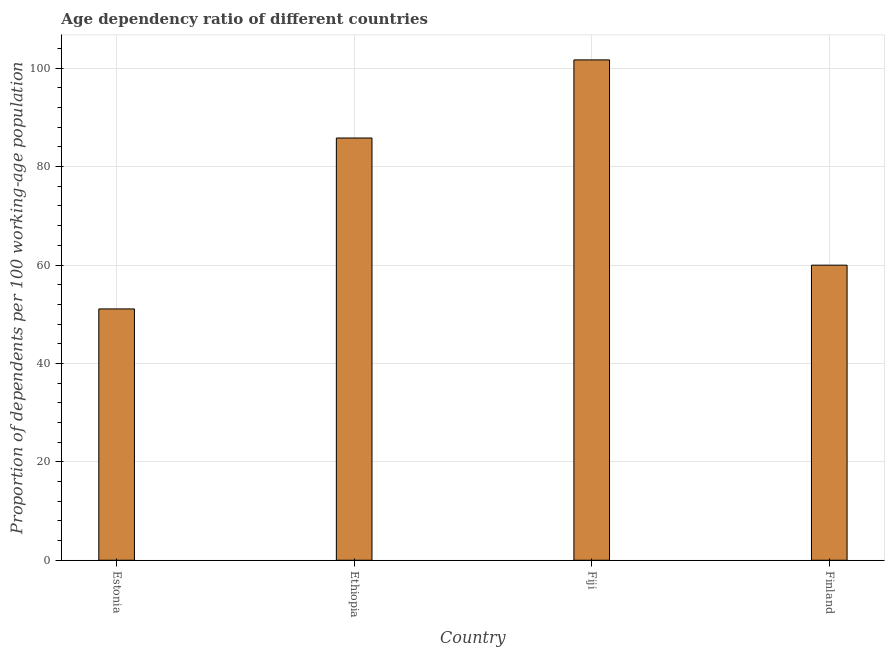Does the graph contain any zero values?
Provide a short and direct response. No. What is the title of the graph?
Your answer should be compact. Age dependency ratio of different countries. What is the label or title of the X-axis?
Your response must be concise. Country. What is the label or title of the Y-axis?
Make the answer very short. Proportion of dependents per 100 working-age population. What is the age dependency ratio in Fiji?
Offer a terse response. 101.69. Across all countries, what is the maximum age dependency ratio?
Your answer should be compact. 101.69. Across all countries, what is the minimum age dependency ratio?
Your answer should be compact. 51.08. In which country was the age dependency ratio maximum?
Your answer should be very brief. Fiji. In which country was the age dependency ratio minimum?
Give a very brief answer. Estonia. What is the sum of the age dependency ratio?
Offer a terse response. 298.56. What is the difference between the age dependency ratio in Estonia and Finland?
Give a very brief answer. -8.9. What is the average age dependency ratio per country?
Offer a terse response. 74.64. What is the median age dependency ratio?
Your answer should be compact. 72.89. What is the ratio of the age dependency ratio in Fiji to that in Finland?
Offer a very short reply. 1.7. Is the age dependency ratio in Estonia less than that in Finland?
Your response must be concise. Yes. Is the difference between the age dependency ratio in Estonia and Ethiopia greater than the difference between any two countries?
Your answer should be compact. No. What is the difference between the highest and the second highest age dependency ratio?
Give a very brief answer. 15.88. Is the sum of the age dependency ratio in Estonia and Finland greater than the maximum age dependency ratio across all countries?
Provide a short and direct response. Yes. What is the difference between the highest and the lowest age dependency ratio?
Keep it short and to the point. 50.61. In how many countries, is the age dependency ratio greater than the average age dependency ratio taken over all countries?
Keep it short and to the point. 2. How many bars are there?
Your response must be concise. 4. Are all the bars in the graph horizontal?
Keep it short and to the point. No. How many countries are there in the graph?
Provide a short and direct response. 4. What is the Proportion of dependents per 100 working-age population in Estonia?
Your answer should be very brief. 51.08. What is the Proportion of dependents per 100 working-age population of Ethiopia?
Keep it short and to the point. 85.82. What is the Proportion of dependents per 100 working-age population in Fiji?
Keep it short and to the point. 101.69. What is the Proportion of dependents per 100 working-age population of Finland?
Offer a very short reply. 59.97. What is the difference between the Proportion of dependents per 100 working-age population in Estonia and Ethiopia?
Provide a short and direct response. -34.74. What is the difference between the Proportion of dependents per 100 working-age population in Estonia and Fiji?
Make the answer very short. -50.61. What is the difference between the Proportion of dependents per 100 working-age population in Estonia and Finland?
Your answer should be compact. -8.9. What is the difference between the Proportion of dependents per 100 working-age population in Ethiopia and Fiji?
Ensure brevity in your answer.  -15.87. What is the difference between the Proportion of dependents per 100 working-age population in Ethiopia and Finland?
Ensure brevity in your answer.  25.84. What is the difference between the Proportion of dependents per 100 working-age population in Fiji and Finland?
Your answer should be very brief. 41.72. What is the ratio of the Proportion of dependents per 100 working-age population in Estonia to that in Ethiopia?
Make the answer very short. 0.59. What is the ratio of the Proportion of dependents per 100 working-age population in Estonia to that in Fiji?
Your answer should be very brief. 0.5. What is the ratio of the Proportion of dependents per 100 working-age population in Estonia to that in Finland?
Your answer should be very brief. 0.85. What is the ratio of the Proportion of dependents per 100 working-age population in Ethiopia to that in Fiji?
Provide a short and direct response. 0.84. What is the ratio of the Proportion of dependents per 100 working-age population in Ethiopia to that in Finland?
Your answer should be compact. 1.43. What is the ratio of the Proportion of dependents per 100 working-age population in Fiji to that in Finland?
Keep it short and to the point. 1.7. 